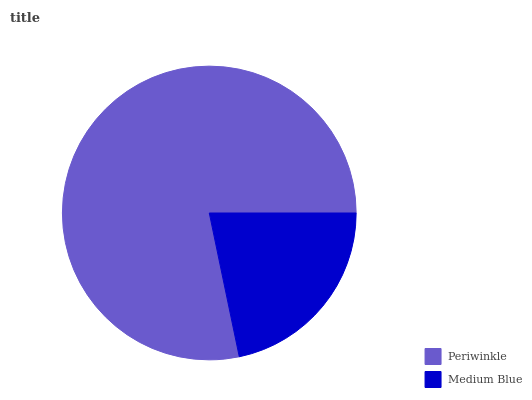Is Medium Blue the minimum?
Answer yes or no. Yes. Is Periwinkle the maximum?
Answer yes or no. Yes. Is Medium Blue the maximum?
Answer yes or no. No. Is Periwinkle greater than Medium Blue?
Answer yes or no. Yes. Is Medium Blue less than Periwinkle?
Answer yes or no. Yes. Is Medium Blue greater than Periwinkle?
Answer yes or no. No. Is Periwinkle less than Medium Blue?
Answer yes or no. No. Is Periwinkle the high median?
Answer yes or no. Yes. Is Medium Blue the low median?
Answer yes or no. Yes. Is Medium Blue the high median?
Answer yes or no. No. Is Periwinkle the low median?
Answer yes or no. No. 